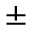<formula> <loc_0><loc_0><loc_500><loc_500>\pm</formula> 